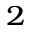Convert formula to latex. <formula><loc_0><loc_0><loc_500><loc_500>_ { 2 }</formula> 